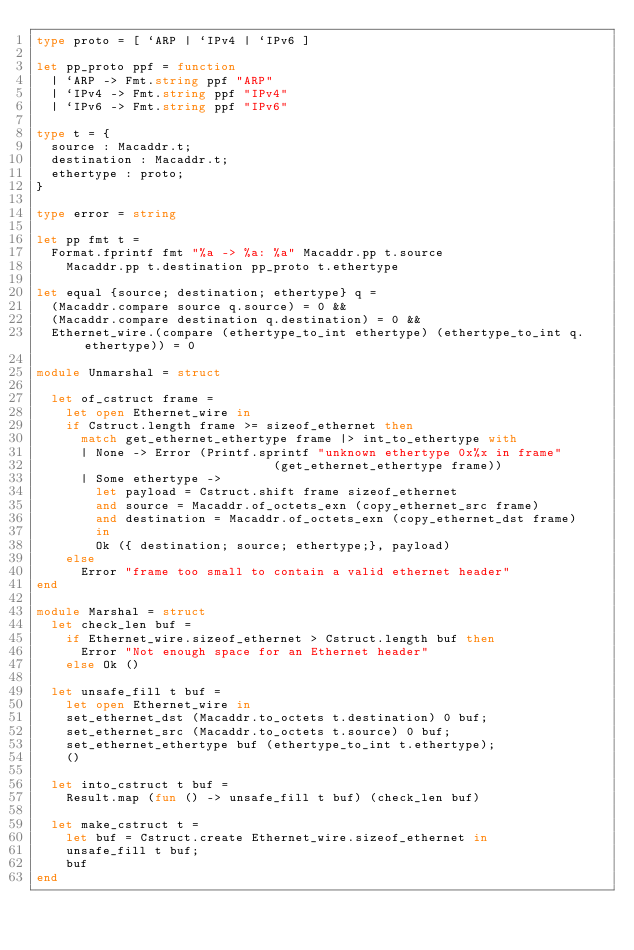Convert code to text. <code><loc_0><loc_0><loc_500><loc_500><_OCaml_>type proto = [ `ARP | `IPv4 | `IPv6 ]

let pp_proto ppf = function
  | `ARP -> Fmt.string ppf "ARP"
  | `IPv4 -> Fmt.string ppf "IPv4"
  | `IPv6 -> Fmt.string ppf "IPv6"

type t = {
  source : Macaddr.t;
  destination : Macaddr.t;
  ethertype : proto;
}

type error = string

let pp fmt t =
  Format.fprintf fmt "%a -> %a: %a" Macaddr.pp t.source
    Macaddr.pp t.destination pp_proto t.ethertype

let equal {source; destination; ethertype} q =
  (Macaddr.compare source q.source) = 0 &&
  (Macaddr.compare destination q.destination) = 0 &&
  Ethernet_wire.(compare (ethertype_to_int ethertype) (ethertype_to_int q.ethertype)) = 0

module Unmarshal = struct

  let of_cstruct frame =
    let open Ethernet_wire in
    if Cstruct.length frame >= sizeof_ethernet then
      match get_ethernet_ethertype frame |> int_to_ethertype with
      | None -> Error (Printf.sprintf "unknown ethertype 0x%x in frame"
                                (get_ethernet_ethertype frame))
      | Some ethertype ->
        let payload = Cstruct.shift frame sizeof_ethernet
        and source = Macaddr.of_octets_exn (copy_ethernet_src frame)
        and destination = Macaddr.of_octets_exn (copy_ethernet_dst frame)
        in
        Ok ({ destination; source; ethertype;}, payload)
    else
      Error "frame too small to contain a valid ethernet header"
end

module Marshal = struct
  let check_len buf =
    if Ethernet_wire.sizeof_ethernet > Cstruct.length buf then
      Error "Not enough space for an Ethernet header"
    else Ok ()

  let unsafe_fill t buf =
    let open Ethernet_wire in
    set_ethernet_dst (Macaddr.to_octets t.destination) 0 buf;
    set_ethernet_src (Macaddr.to_octets t.source) 0 buf;
    set_ethernet_ethertype buf (ethertype_to_int t.ethertype);
    ()

  let into_cstruct t buf =
    Result.map (fun () -> unsafe_fill t buf) (check_len buf)

  let make_cstruct t =
    let buf = Cstruct.create Ethernet_wire.sizeof_ethernet in
    unsafe_fill t buf;
    buf
end
</code> 